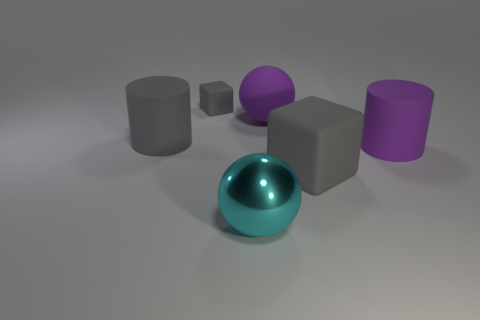Add 2 cyan metallic balls. How many objects exist? 8 Subtract all balls. How many objects are left? 4 Add 1 large purple rubber objects. How many large purple rubber objects exist? 3 Subtract 0 yellow cubes. How many objects are left? 6 Subtract all big metal spheres. Subtract all blocks. How many objects are left? 3 Add 1 large gray matte blocks. How many large gray matte blocks are left? 2 